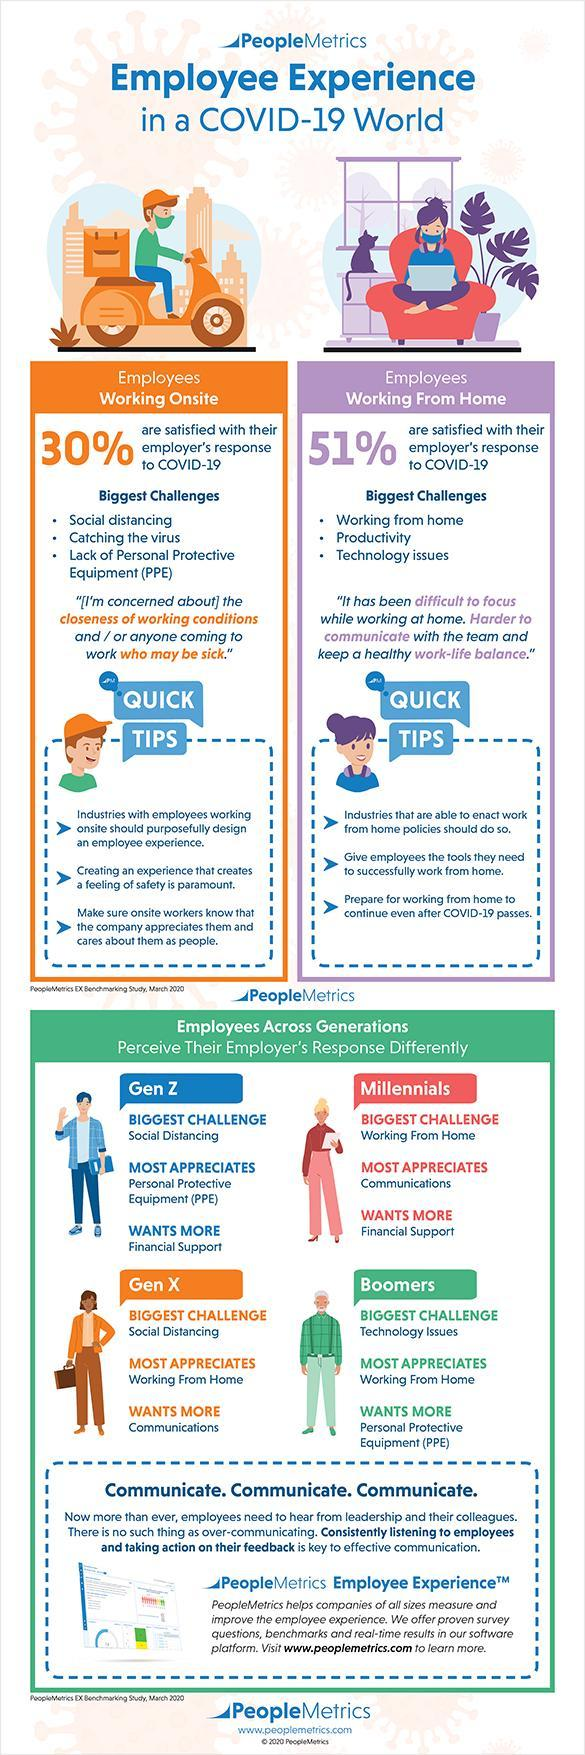Other than productivity, what are the biggest challenges faced by employees working from home
Answer the question with a short phrase. working from home, technology issues Which generation wants more Financial Support Gen Z, Millennials what % of employees working onsite are not satisfied with their employer's response to COVID-19 70 Which generations find social distancing the biggest challenge Gen Z, Gen X Employees working from where are more satisfied with their employers response to COVID-19 home what % of employees working from home are not satisfied with their employer's response to COVID-19 49 Which generations most appreciates working from home Gen X, Boomers 